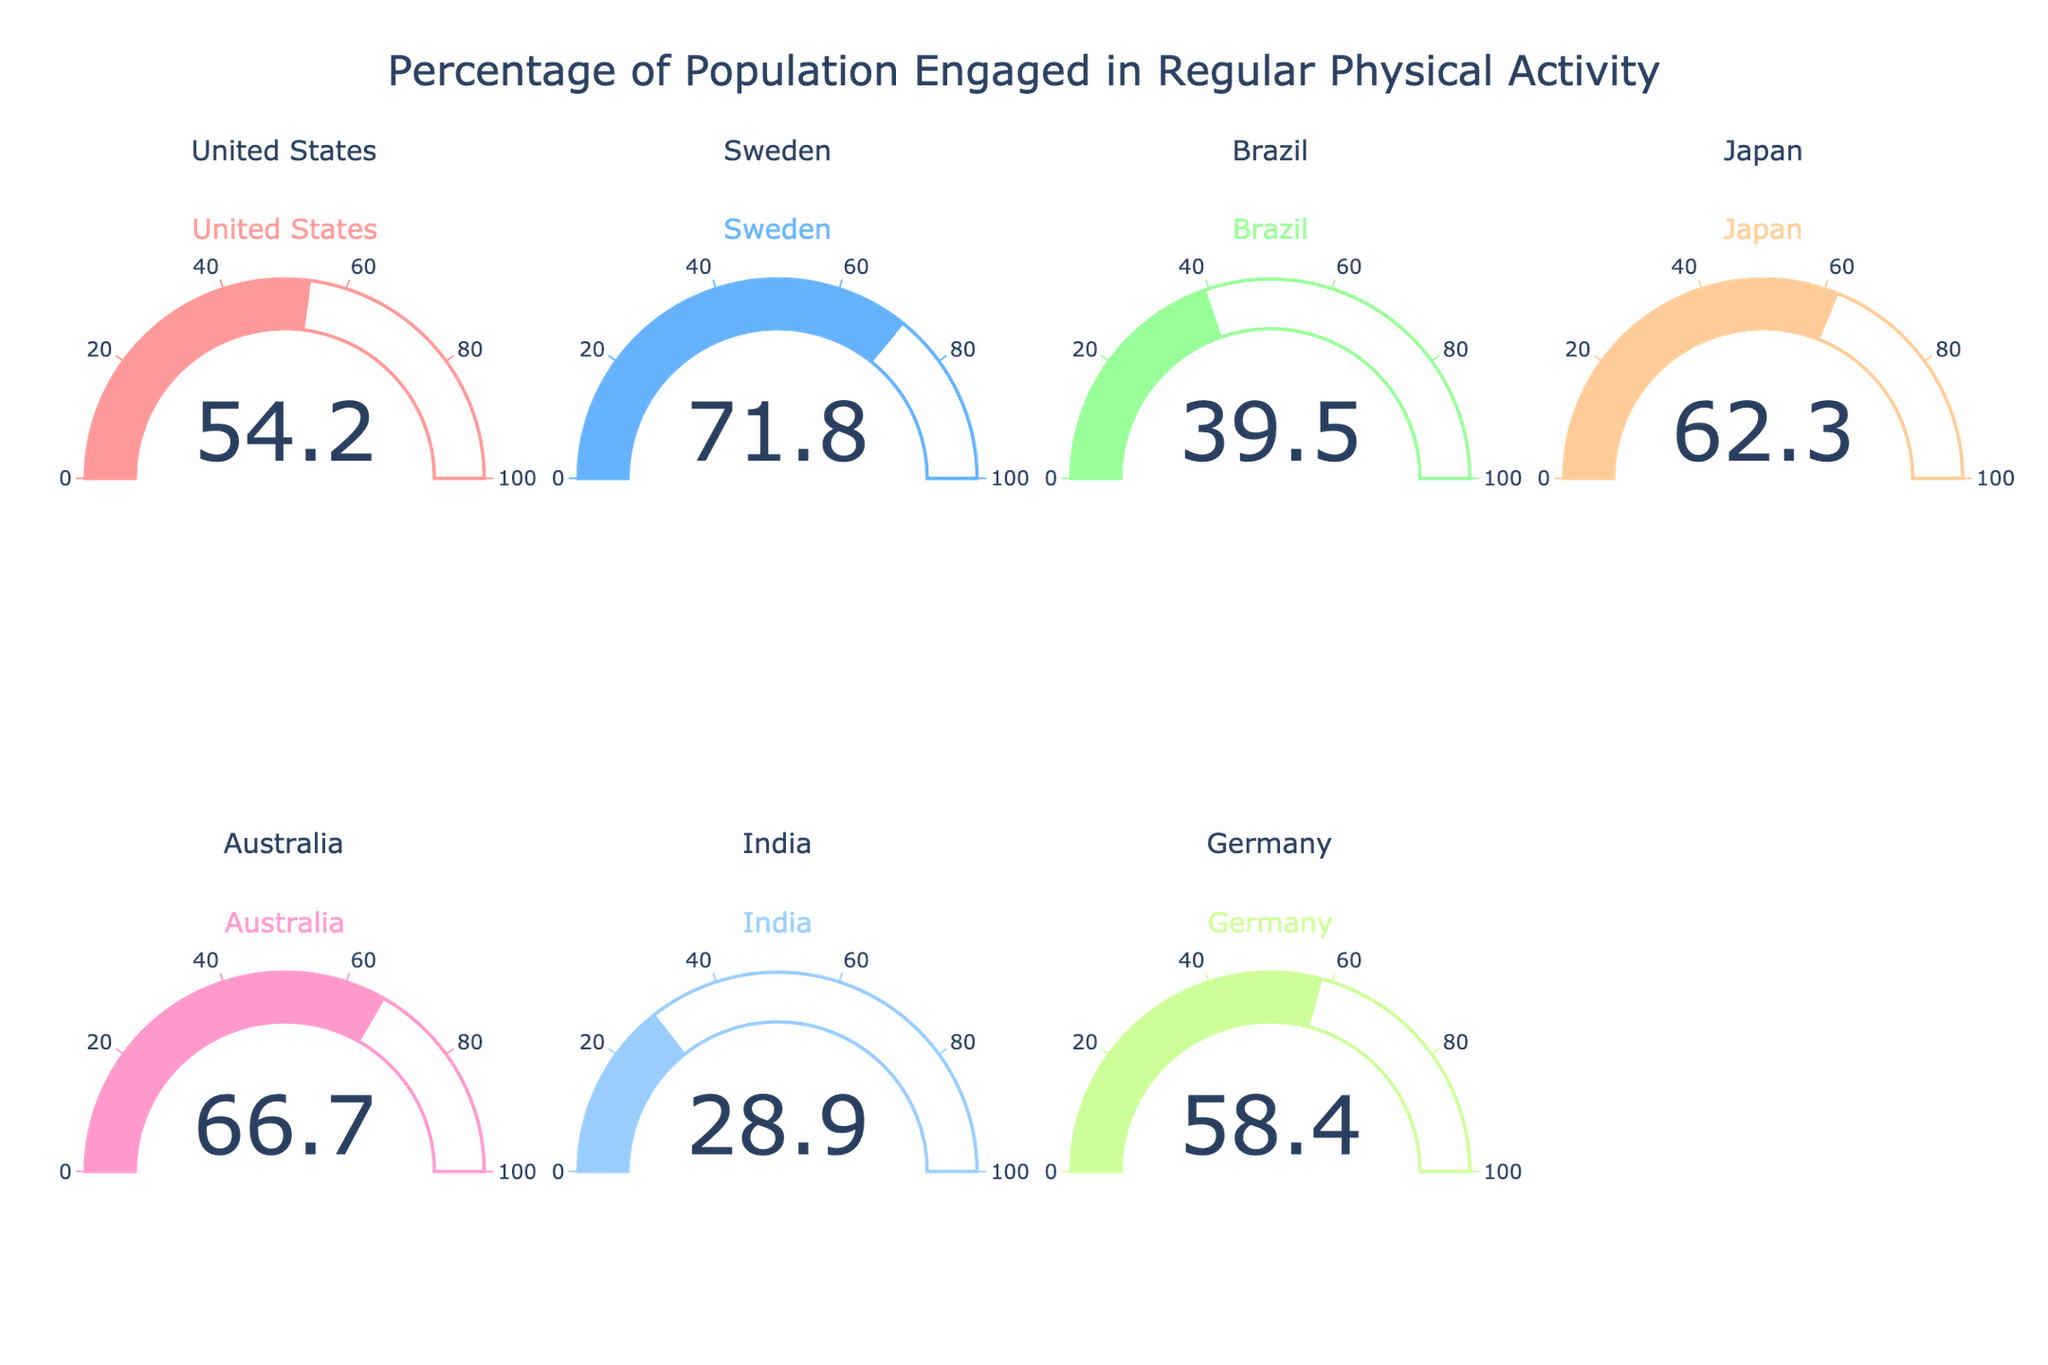What's the title of the figure? The title is displayed at the top of the figure, centered and in a large font size.
Answer: Percentage of Population Engaged in Regular Physical Activity Which country has the highest percentage of population engaged in regular physical activity? By comparing the gauge values displayed for each country, the highest percentage can be identified.
Answer: Sweden What is the difference in the percentage of population engaged in regular physical activity between India and Japan? Subtract the percentage of India from that of Japan: 62.3 - 28.9.
Answer: 33.4 Are there more countries with a percentage above 60% or below 60%? Count the number of countries with percentages above and below 60% respectively: Above (Sweden, Japan, Australia) = 3; Below (United States, Brazil, India, Germany) = 4.
Answer: Below Which country has the lowest percentage of population engaged in regular physical activity? Find the smallest value among all gauge values.
Answer: India What's the average percentage of population engaged in regular physical activity across all countries? Sum all the percentages and divide by the number of countries: (54.2 + 71.8 + 39.5 + 62.3 + 66.7 + 28.9 + 58.4) / 7.
Answer: 54.54 Which countries have a percentage of population engaged in regular physical activity greater than the average percentage? Compare each country's value to the average percentage of 54.54: Above the average are Sweden, Japan, Australia, and Germany.
Answer: Sweden, Japan, Australia, Germany How many countries have their gauge's bar color as blue? Identify the countries with gauge's bar color corresponding to blue. Possible colors considered for blue are: #66B2FF and #99CCFF.
Answer: 2 countries (Japan, Germany) Is there any country with exactly 50% of population engaged in regular physical activity? Check the gauge values for the presence of a 50%.
Answer: No Which country has a percentage closest to the global average percentage? Calculate the differences of each country's percentage from the average of 54.54 and find the smallest difference: United States (54.2 is closest to 54.54).
Answer: United States 